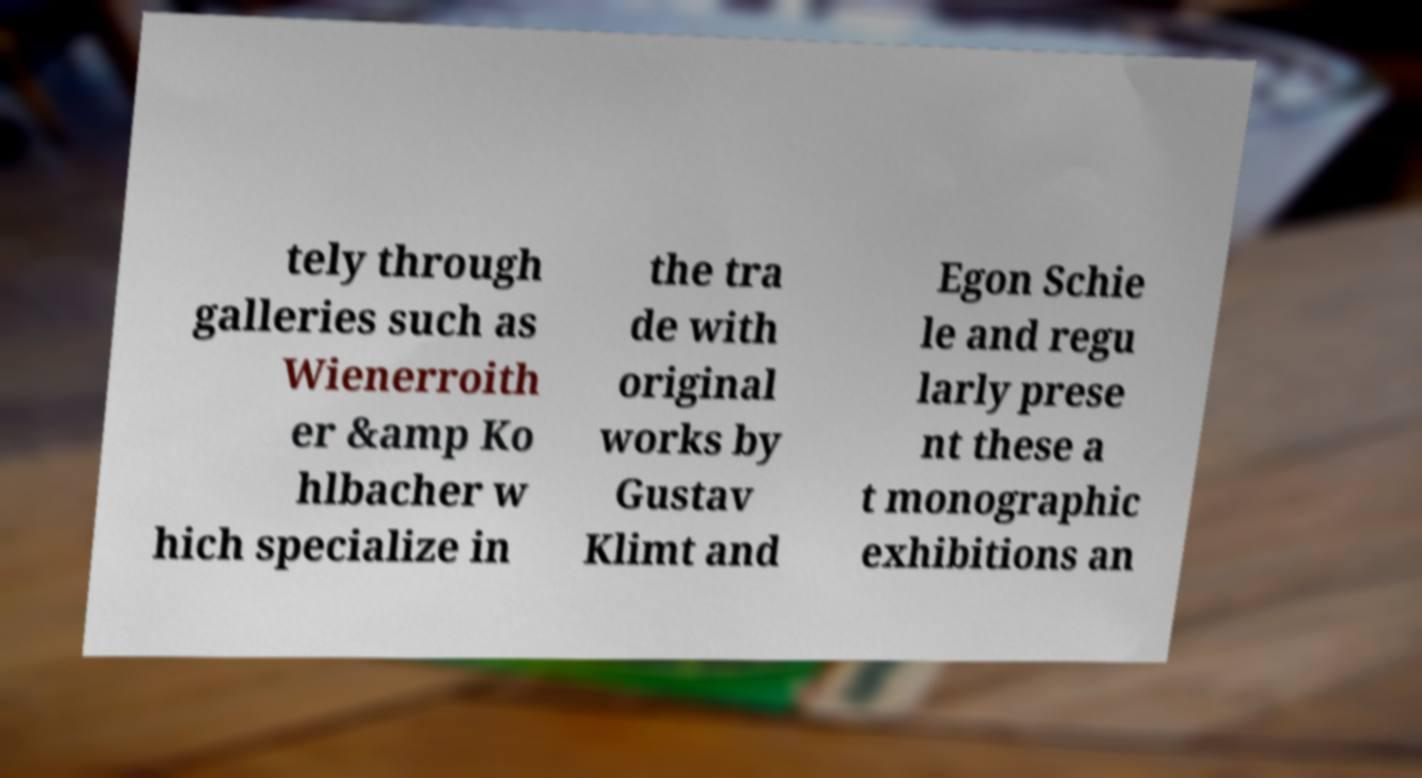I need the written content from this picture converted into text. Can you do that? tely through galleries such as Wienerroith er &amp Ko hlbacher w hich specialize in the tra de with original works by Gustav Klimt and Egon Schie le and regu larly prese nt these a t monographic exhibitions an 